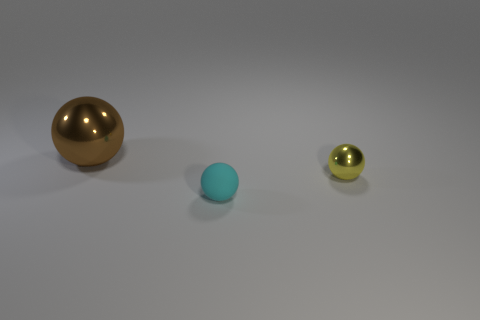Subtract all big shiny spheres. How many spheres are left? 2 Add 1 big metal spheres. How many objects exist? 4 Subtract 0 brown blocks. How many objects are left? 3 Subtract all green spheres. Subtract all gray cylinders. How many spheres are left? 3 Subtract all small blocks. Subtract all tiny yellow objects. How many objects are left? 2 Add 3 metal objects. How many metal objects are left? 5 Add 1 tiny metal cylinders. How many tiny metal cylinders exist? 1 